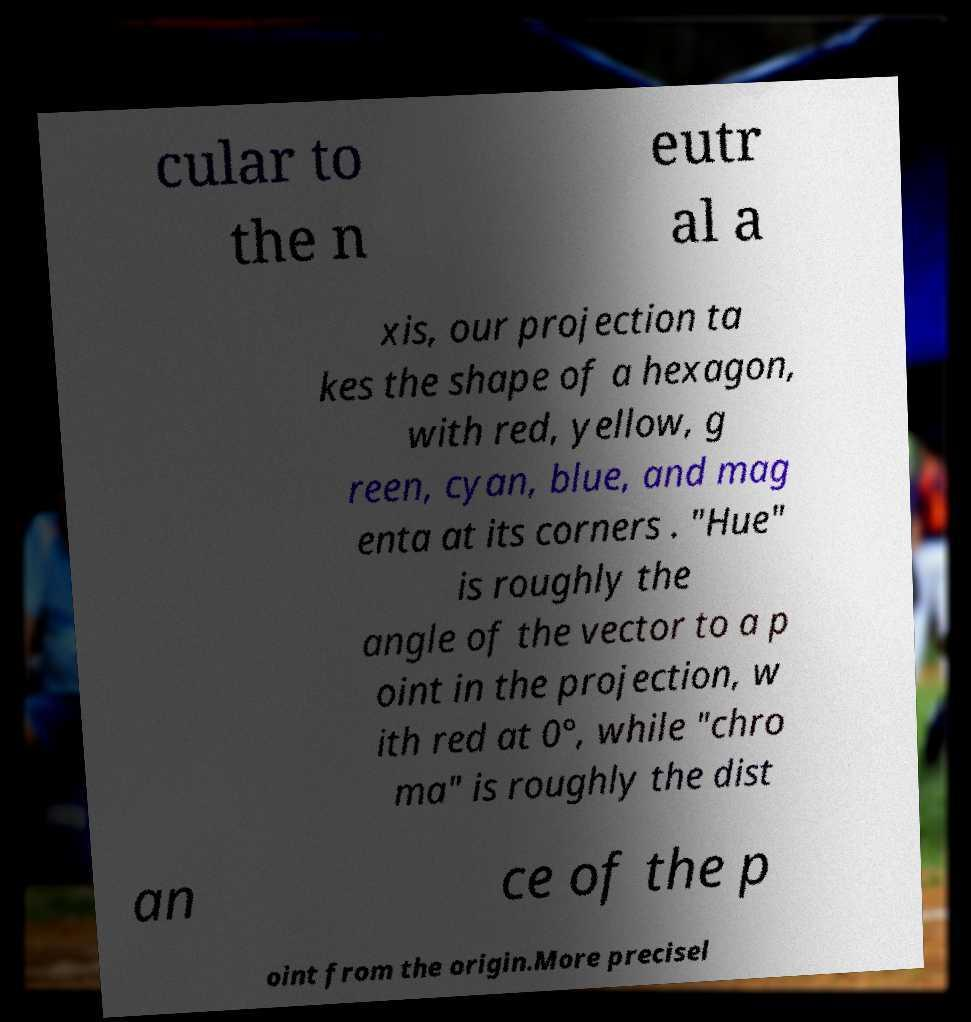Could you assist in decoding the text presented in this image and type it out clearly? cular to the n eutr al a xis, our projection ta kes the shape of a hexagon, with red, yellow, g reen, cyan, blue, and mag enta at its corners . "Hue" is roughly the angle of the vector to a p oint in the projection, w ith red at 0°, while "chro ma" is roughly the dist an ce of the p oint from the origin.More precisel 